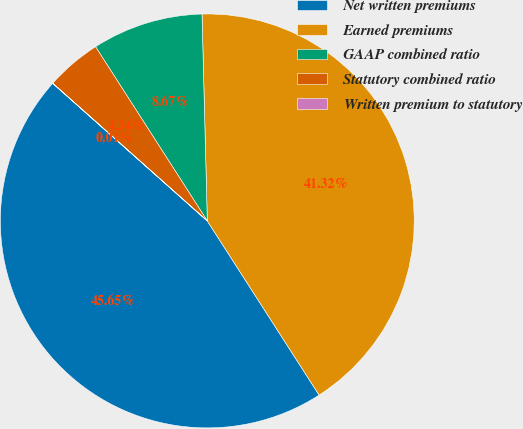Convert chart. <chart><loc_0><loc_0><loc_500><loc_500><pie_chart><fcel>Net written premiums<fcel>Earned premiums<fcel>GAAP combined ratio<fcel>Statutory combined ratio<fcel>Written premium to statutory<nl><fcel>45.65%<fcel>41.32%<fcel>8.67%<fcel>4.34%<fcel>0.01%<nl></chart> 